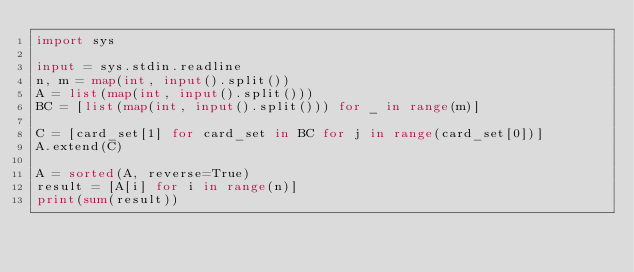Convert code to text. <code><loc_0><loc_0><loc_500><loc_500><_Python_>import sys

input = sys.stdin.readline
n, m = map(int, input().split())
A = list(map(int, input().split()))
BC = [list(map(int, input().split())) for _ in range(m)]
 
C = [card_set[1] for card_set in BC for j in range(card_set[0])]
A.extend(C)
 
A = sorted(A, reverse=True)
result = [A[i] for i in range(n)]
print(sum(result))</code> 